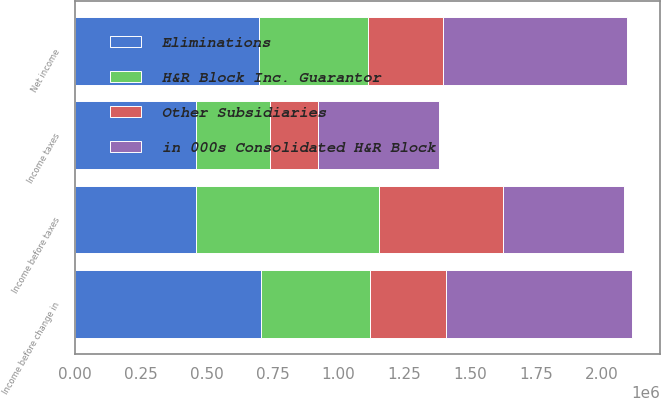<chart> <loc_0><loc_0><loc_500><loc_500><stacked_bar_chart><ecel><fcel>Income before taxes<fcel>Income taxes<fcel>Income before change in<fcel>Net income<nl><fcel>in 000s Consolidated H&R Block<fcel>459974<fcel>459901<fcel>704256<fcel>697897<nl><fcel>H&R Block Inc. Guarantor<fcel>694869<fcel>280956<fcel>413913<fcel>413913<nl><fcel>Other Subsidiaries<fcel>469661<fcel>179092<fcel>290569<fcel>284210<nl><fcel>Eliminations<fcel>459974<fcel>460048<fcel>704482<fcel>698123<nl></chart> 